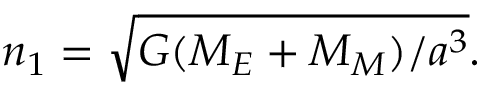Convert formula to latex. <formula><loc_0><loc_0><loc_500><loc_500>n _ { 1 } = \sqrt { G ( M _ { E } + M _ { M } ) / a ^ { 3 } } .</formula> 